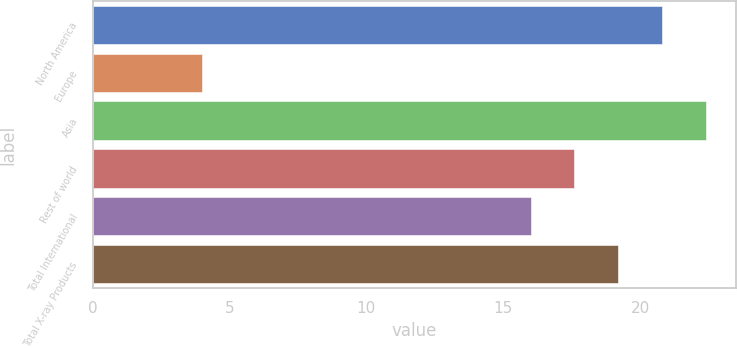<chart> <loc_0><loc_0><loc_500><loc_500><bar_chart><fcel>North America<fcel>Europe<fcel>Asia<fcel>Rest of world<fcel>Total International<fcel>Total X-ray Products<nl><fcel>20.8<fcel>4<fcel>22.4<fcel>17.6<fcel>16<fcel>19.2<nl></chart> 